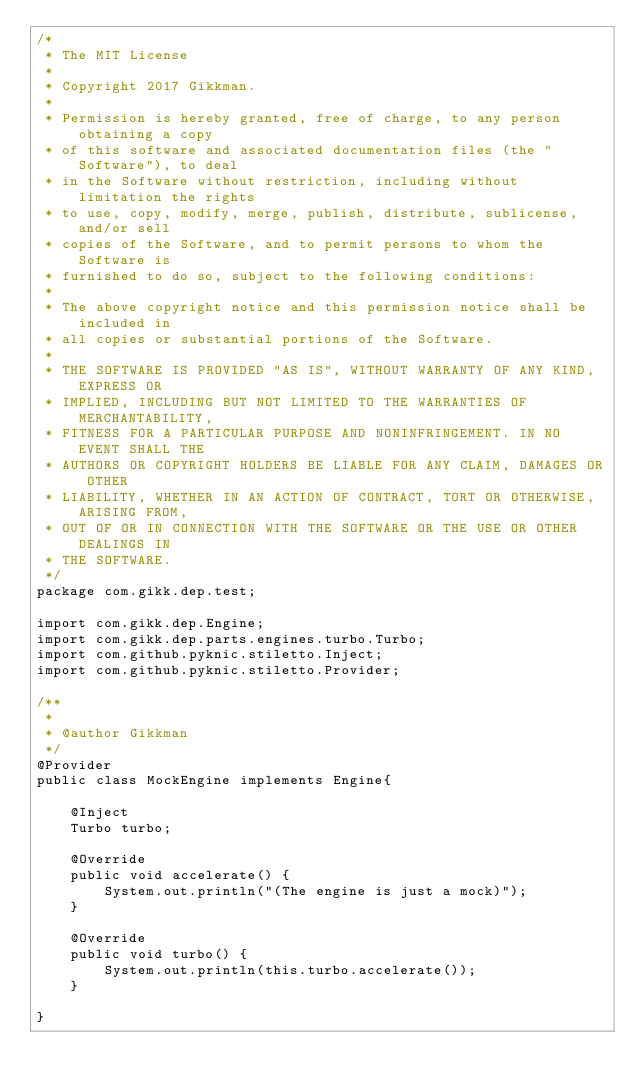Convert code to text. <code><loc_0><loc_0><loc_500><loc_500><_Java_>/*
 * The MIT License
 *
 * Copyright 2017 Gikkman.
 *
 * Permission is hereby granted, free of charge, to any person obtaining a copy
 * of this software and associated documentation files (the "Software"), to deal
 * in the Software without restriction, including without limitation the rights
 * to use, copy, modify, merge, publish, distribute, sublicense, and/or sell
 * copies of the Software, and to permit persons to whom the Software is
 * furnished to do so, subject to the following conditions:
 *
 * The above copyright notice and this permission notice shall be included in
 * all copies or substantial portions of the Software.
 *
 * THE SOFTWARE IS PROVIDED "AS IS", WITHOUT WARRANTY OF ANY KIND, EXPRESS OR
 * IMPLIED, INCLUDING BUT NOT LIMITED TO THE WARRANTIES OF MERCHANTABILITY,
 * FITNESS FOR A PARTICULAR PURPOSE AND NONINFRINGEMENT. IN NO EVENT SHALL THE
 * AUTHORS OR COPYRIGHT HOLDERS BE LIABLE FOR ANY CLAIM, DAMAGES OR OTHER
 * LIABILITY, WHETHER IN AN ACTION OF CONTRACT, TORT OR OTHERWISE, ARISING FROM,
 * OUT OF OR IN CONNECTION WITH THE SOFTWARE OR THE USE OR OTHER DEALINGS IN
 * THE SOFTWARE.
 */
package com.gikk.dep.test;

import com.gikk.dep.Engine;
import com.gikk.dep.parts.engines.turbo.Turbo;
import com.github.pyknic.stiletto.Inject;
import com.github.pyknic.stiletto.Provider;

/**
 *
 * @author Gikkman
 */
@Provider
public class MockEngine implements Engine{

    @Inject
    Turbo turbo;
    
    @Override
    public void accelerate() {
        System.out.println("(The engine is just a mock)");
    }

    @Override
    public void turbo() {
        System.out.println(this.turbo.accelerate());
    }
    
}
</code> 